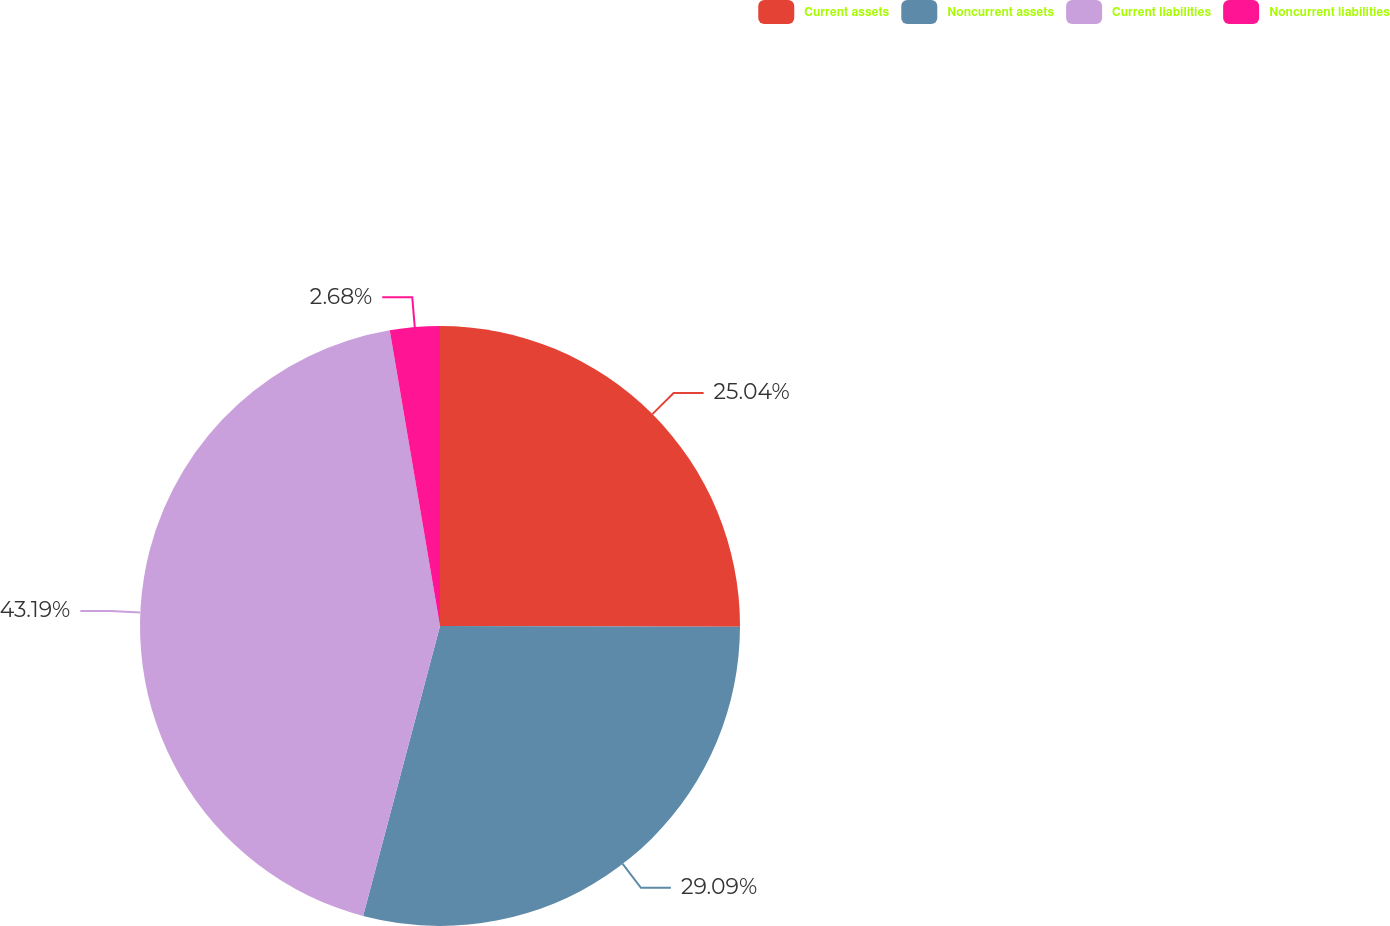<chart> <loc_0><loc_0><loc_500><loc_500><pie_chart><fcel>Current assets<fcel>Noncurrent assets<fcel>Current liabilities<fcel>Noncurrent liabilities<nl><fcel>25.04%<fcel>29.09%<fcel>43.2%<fcel>2.68%<nl></chart> 